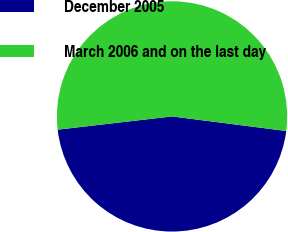Convert chart to OTSL. <chart><loc_0><loc_0><loc_500><loc_500><pie_chart><fcel>December 2005<fcel>March 2006 and on the last day<nl><fcel>46.15%<fcel>53.85%<nl></chart> 